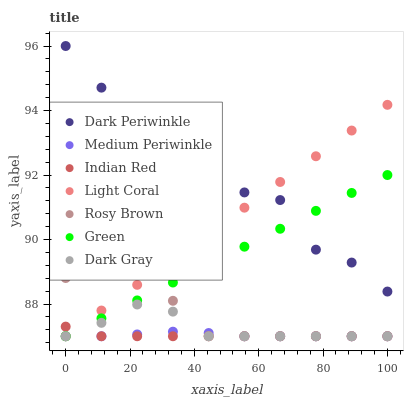Does Indian Red have the minimum area under the curve?
Answer yes or no. Yes. Does Dark Periwinkle have the maximum area under the curve?
Answer yes or no. Yes. Does Rosy Brown have the minimum area under the curve?
Answer yes or no. No. Does Rosy Brown have the maximum area under the curve?
Answer yes or no. No. Is Light Coral the smoothest?
Answer yes or no. Yes. Is Dark Periwinkle the roughest?
Answer yes or no. Yes. Is Rosy Brown the smoothest?
Answer yes or no. No. Is Rosy Brown the roughest?
Answer yes or no. No. Does Dark Gray have the lowest value?
Answer yes or no. Yes. Does Dark Periwinkle have the lowest value?
Answer yes or no. No. Does Dark Periwinkle have the highest value?
Answer yes or no. Yes. Does Rosy Brown have the highest value?
Answer yes or no. No. Is Rosy Brown less than Dark Periwinkle?
Answer yes or no. Yes. Is Dark Periwinkle greater than Medium Periwinkle?
Answer yes or no. Yes. Does Light Coral intersect Rosy Brown?
Answer yes or no. Yes. Is Light Coral less than Rosy Brown?
Answer yes or no. No. Is Light Coral greater than Rosy Brown?
Answer yes or no. No. Does Rosy Brown intersect Dark Periwinkle?
Answer yes or no. No. 